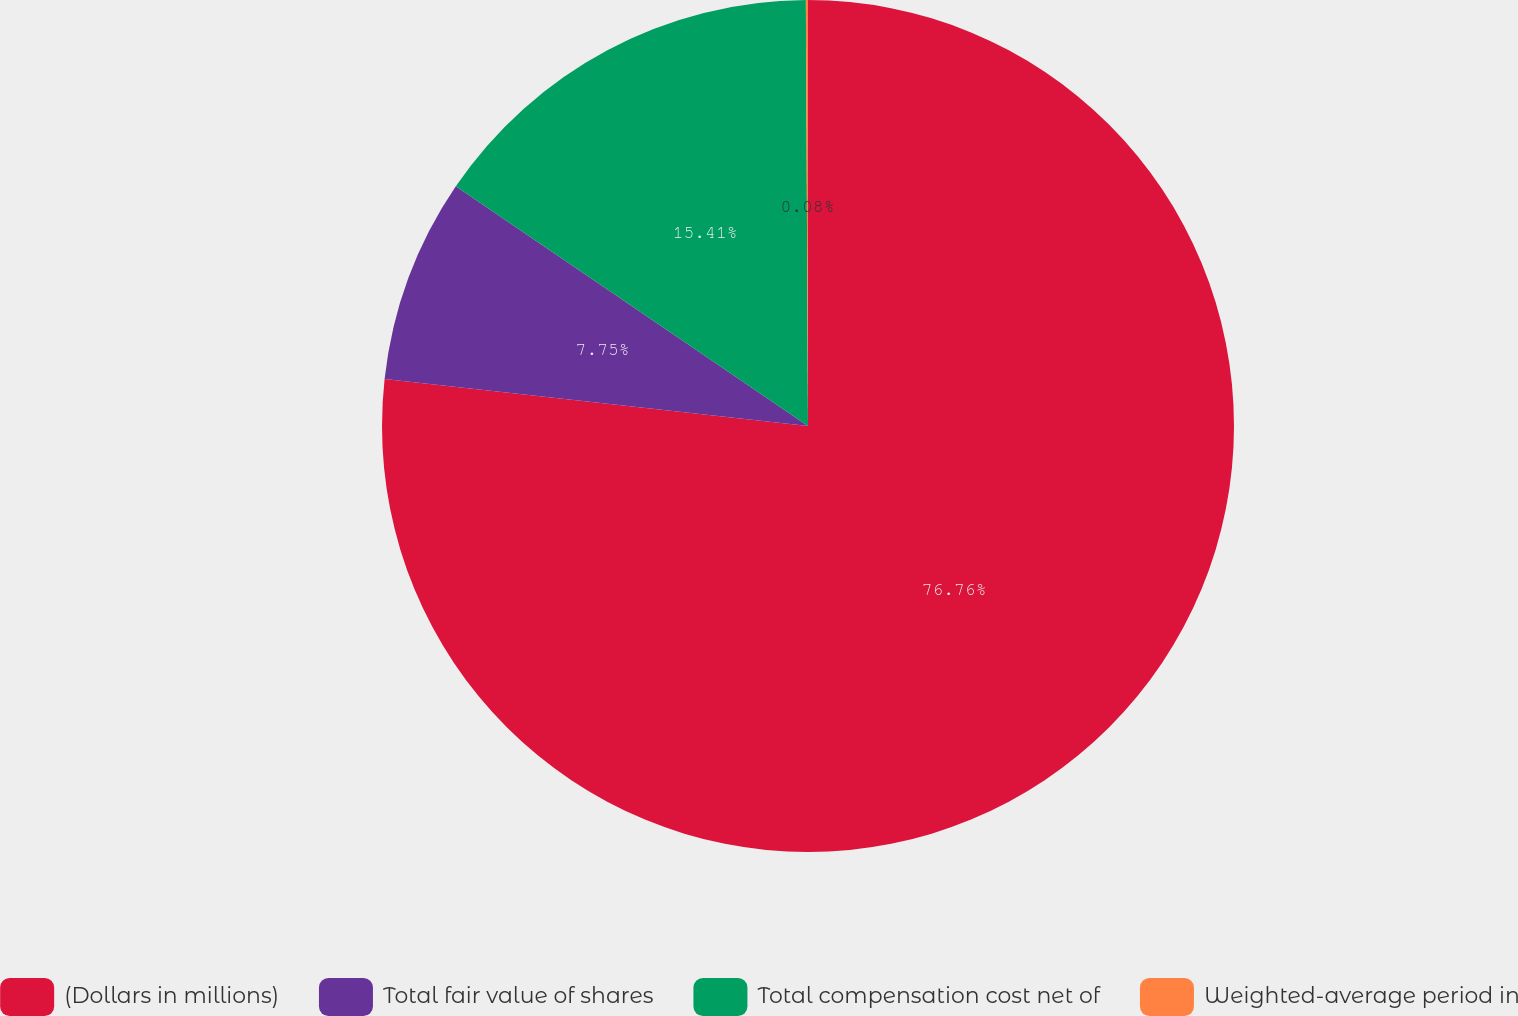<chart> <loc_0><loc_0><loc_500><loc_500><pie_chart><fcel>(Dollars in millions)<fcel>Total fair value of shares<fcel>Total compensation cost net of<fcel>Weighted-average period in<nl><fcel>76.76%<fcel>7.75%<fcel>15.41%<fcel>0.08%<nl></chart> 